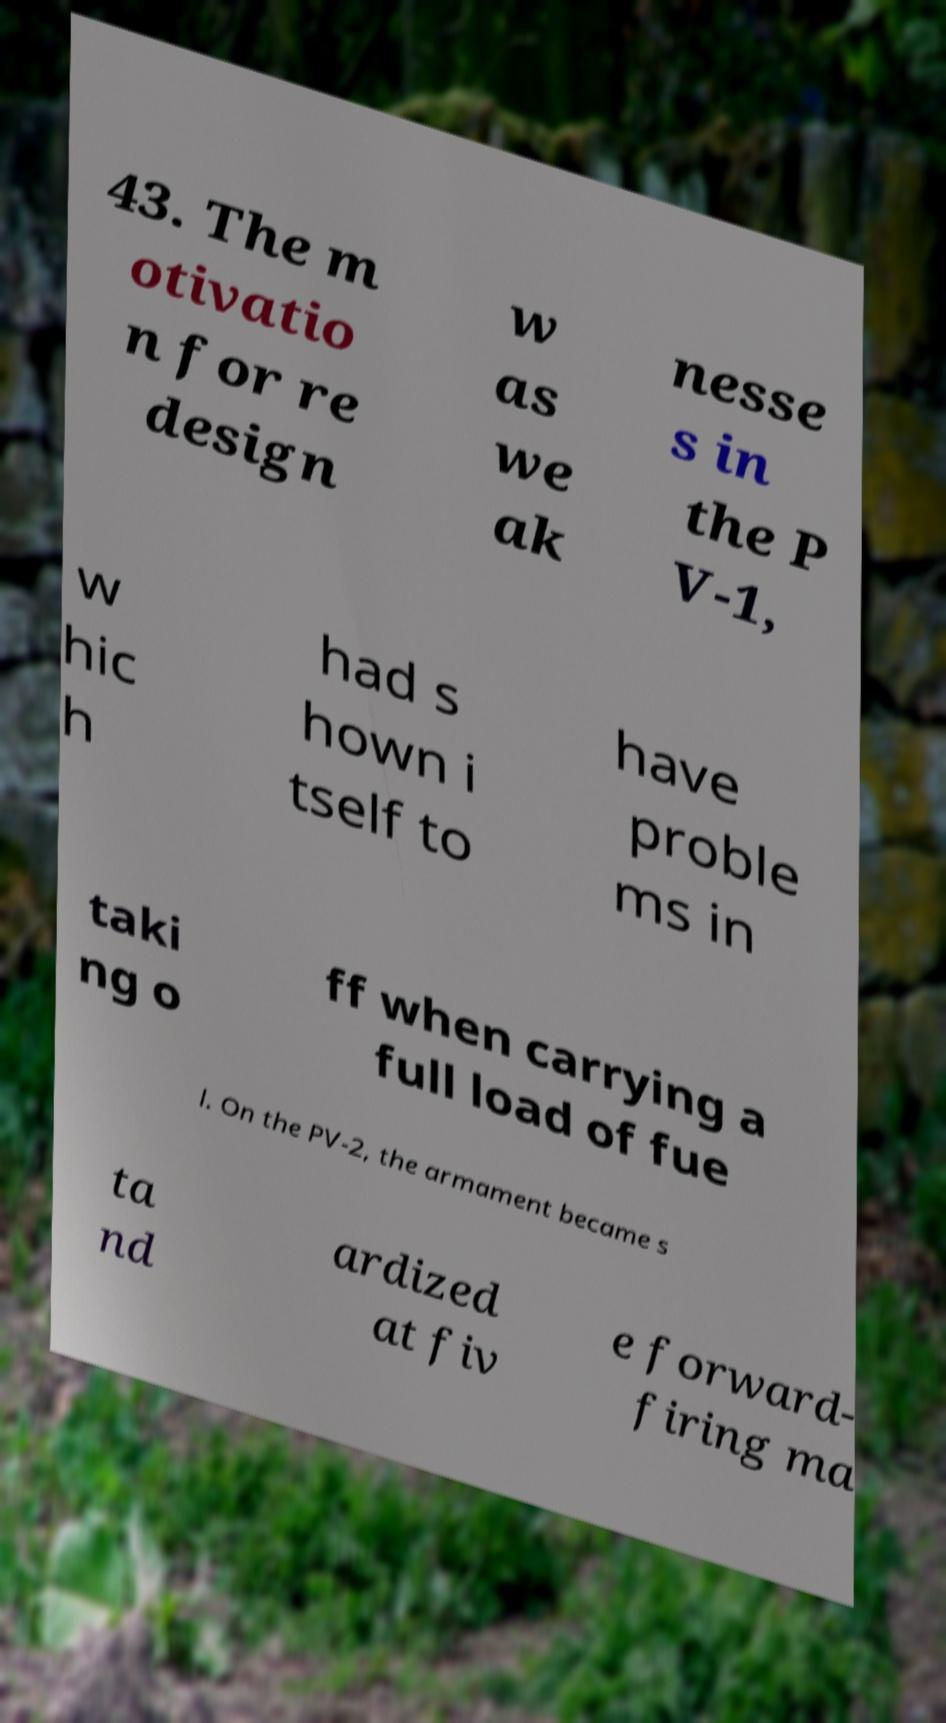For documentation purposes, I need the text within this image transcribed. Could you provide that? 43. The m otivatio n for re design w as we ak nesse s in the P V-1, w hic h had s hown i tself to have proble ms in taki ng o ff when carrying a full load of fue l. On the PV-2, the armament became s ta nd ardized at fiv e forward- firing ma 